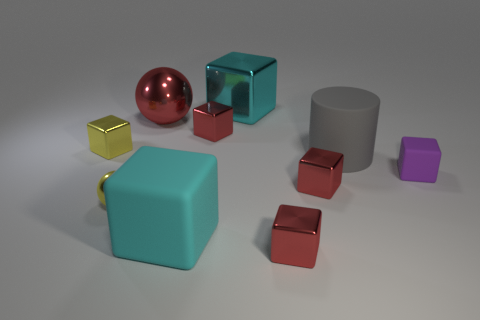Subtract all brown balls. How many red blocks are left? 3 Subtract all cyan blocks. How many blocks are left? 5 Subtract all red shiny cubes. How many cubes are left? 4 Subtract all cyan blocks. Subtract all purple cylinders. How many blocks are left? 5 Subtract all spheres. How many objects are left? 8 Add 5 small red metallic things. How many small red metallic things are left? 8 Add 1 small green balls. How many small green balls exist? 1 Subtract 0 cyan spheres. How many objects are left? 10 Subtract all big gray matte cylinders. Subtract all big red metal things. How many objects are left? 8 